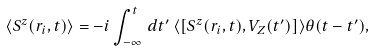<formula> <loc_0><loc_0><loc_500><loc_500>\langle S ^ { z } ( { r } _ { i } , t ) \rangle = - i \int _ { - \infty } ^ { t } \, d t ^ { \prime } \, \langle [ S ^ { z } ( { r } _ { i } , t ) , V _ { Z } ( t ^ { \prime } ) ] \rangle \theta ( t - t ^ { \prime } ) ,</formula> 